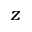<formula> <loc_0><loc_0><loc_500><loc_500>z</formula> 